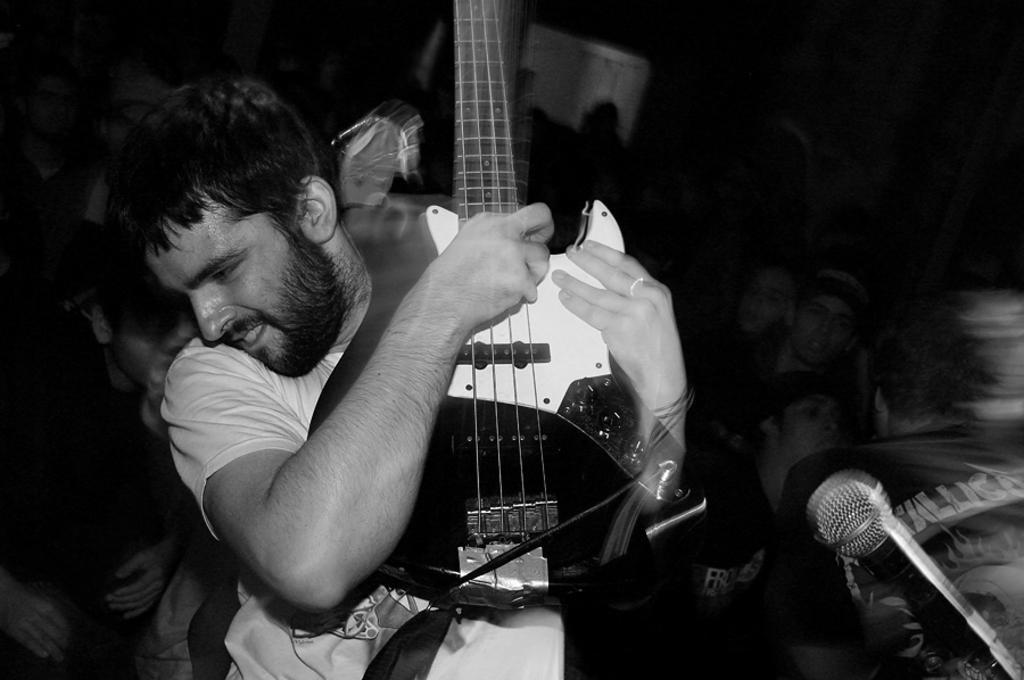How would you summarize this image in a sentence or two? In this image there is a man holding a guitar in his arms. we can also see a mic on the right side of the image. This image is slightly blurred and in the background we can see few people. 